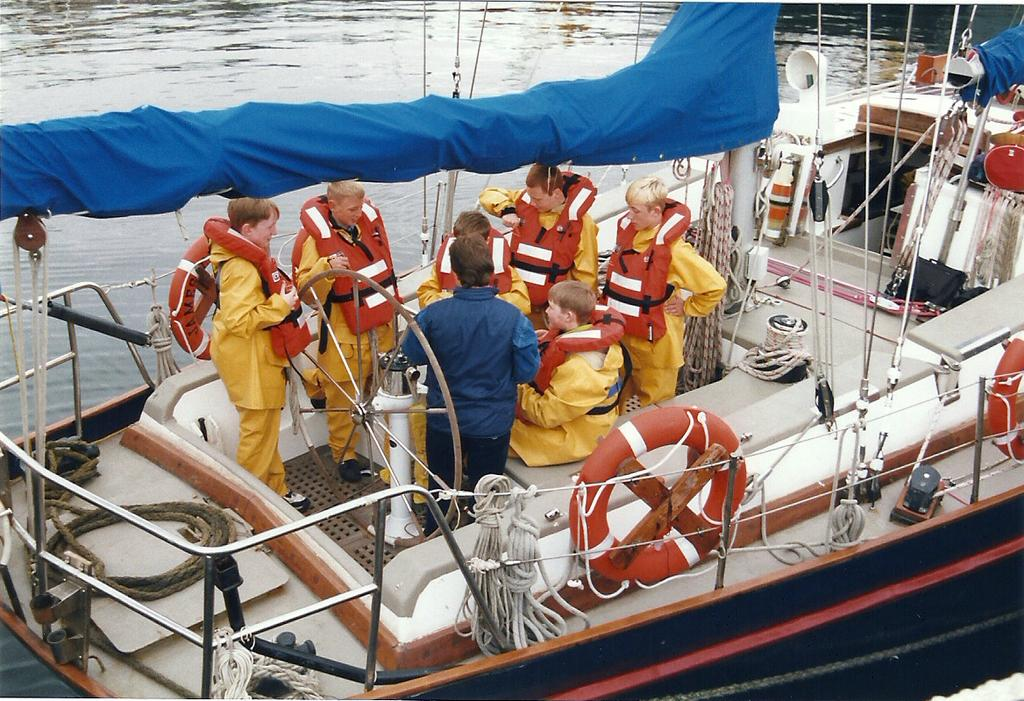What is the main subject of the image? The main subject of the image is a boat. Where is the boat located in the image? The boat is on the water in the image. Are there any people on the boat? Yes, there are people on the boat. What additional items can be seen on the boat? Swim tubes, ropes, and other objects are present on the boat. What type of test is being conducted on the boat in the image? There is no test being conducted on the boat in the image; it is a recreational boat with people on board. How many people are sleeping on the boat in the image? There is no indication that anyone is sleeping on the boat in the image; the people are likely enjoying their time on the water. 